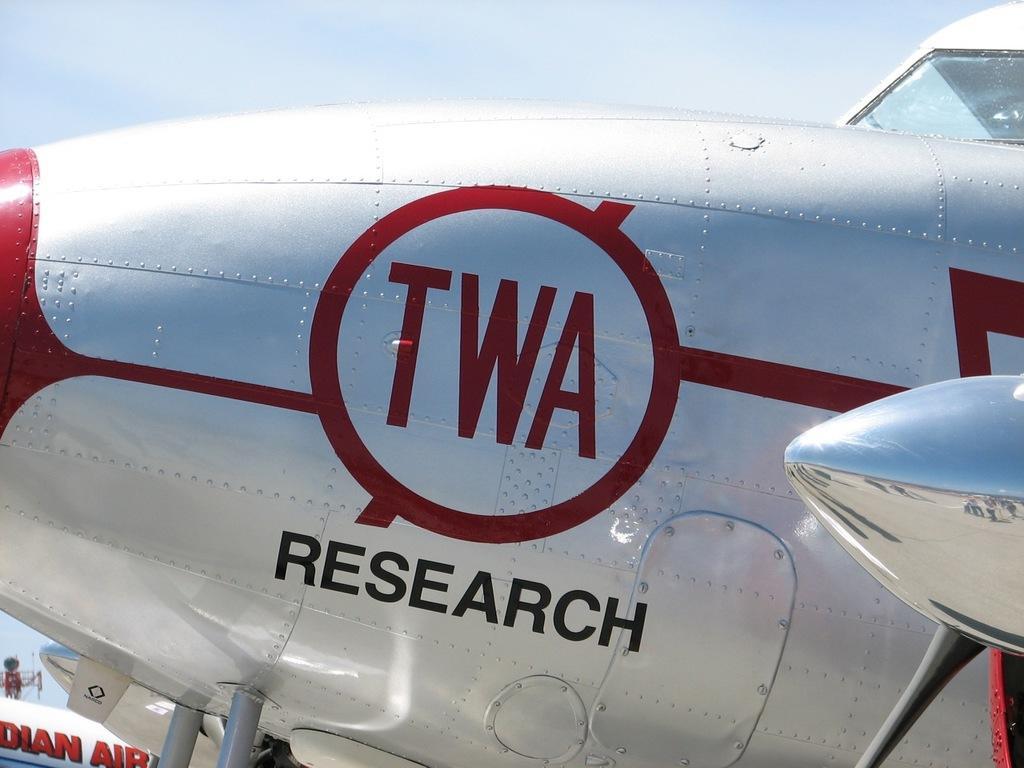Could you give a brief overview of what you see in this image? In this image I can see an aircraft which is white, red and black in color. In the background I can see few other aircrafts, a tower and the sky. 